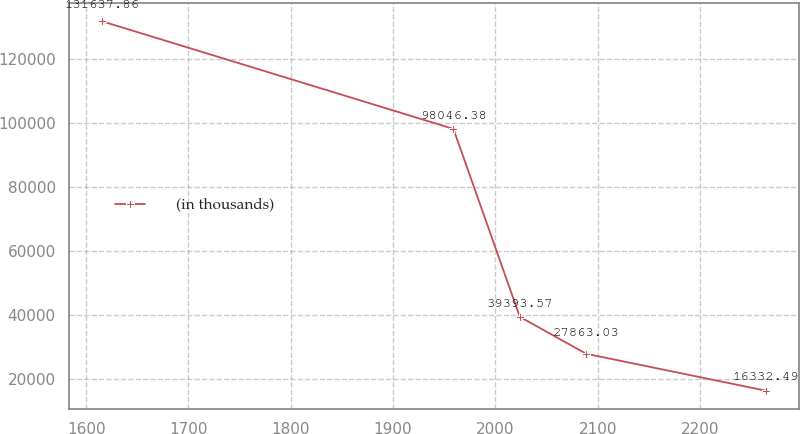Convert chart. <chart><loc_0><loc_0><loc_500><loc_500><line_chart><ecel><fcel>(in thousands)<nl><fcel>1615.7<fcel>131638<nl><fcel>1959.05<fcel>98046.4<nl><fcel>2023.93<fcel>39393.6<nl><fcel>2088.81<fcel>27863<nl><fcel>2264.54<fcel>16332.5<nl></chart> 